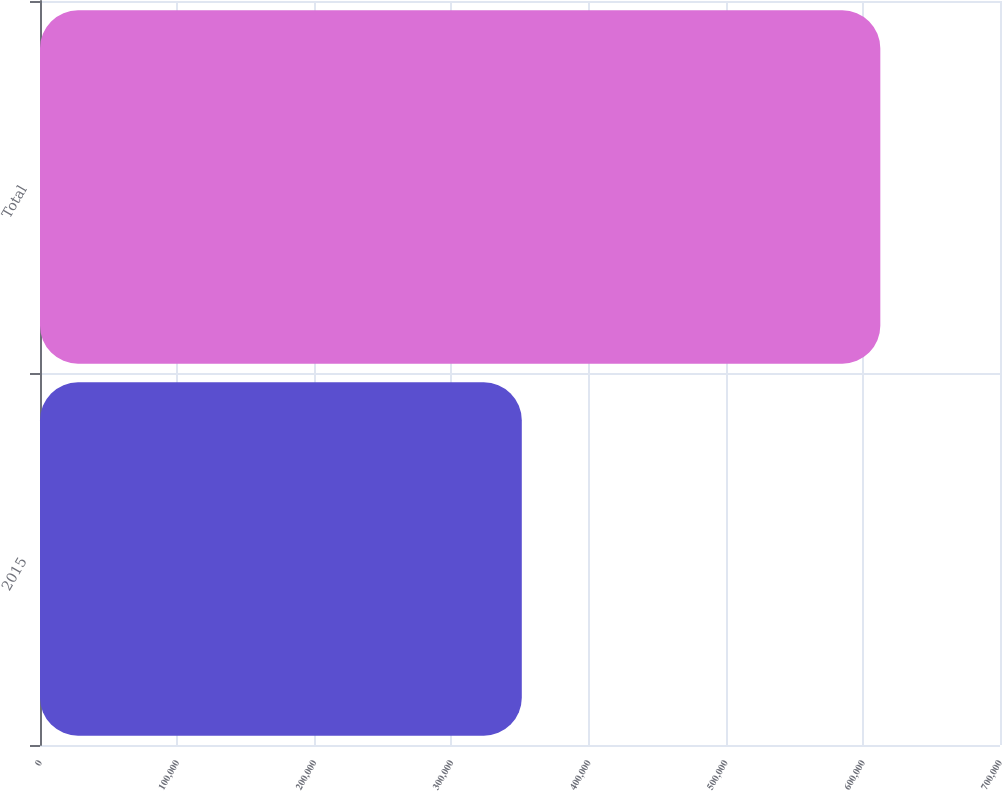<chart> <loc_0><loc_0><loc_500><loc_500><bar_chart><fcel>2015<fcel>Total<nl><fcel>351308<fcel>612735<nl></chart> 